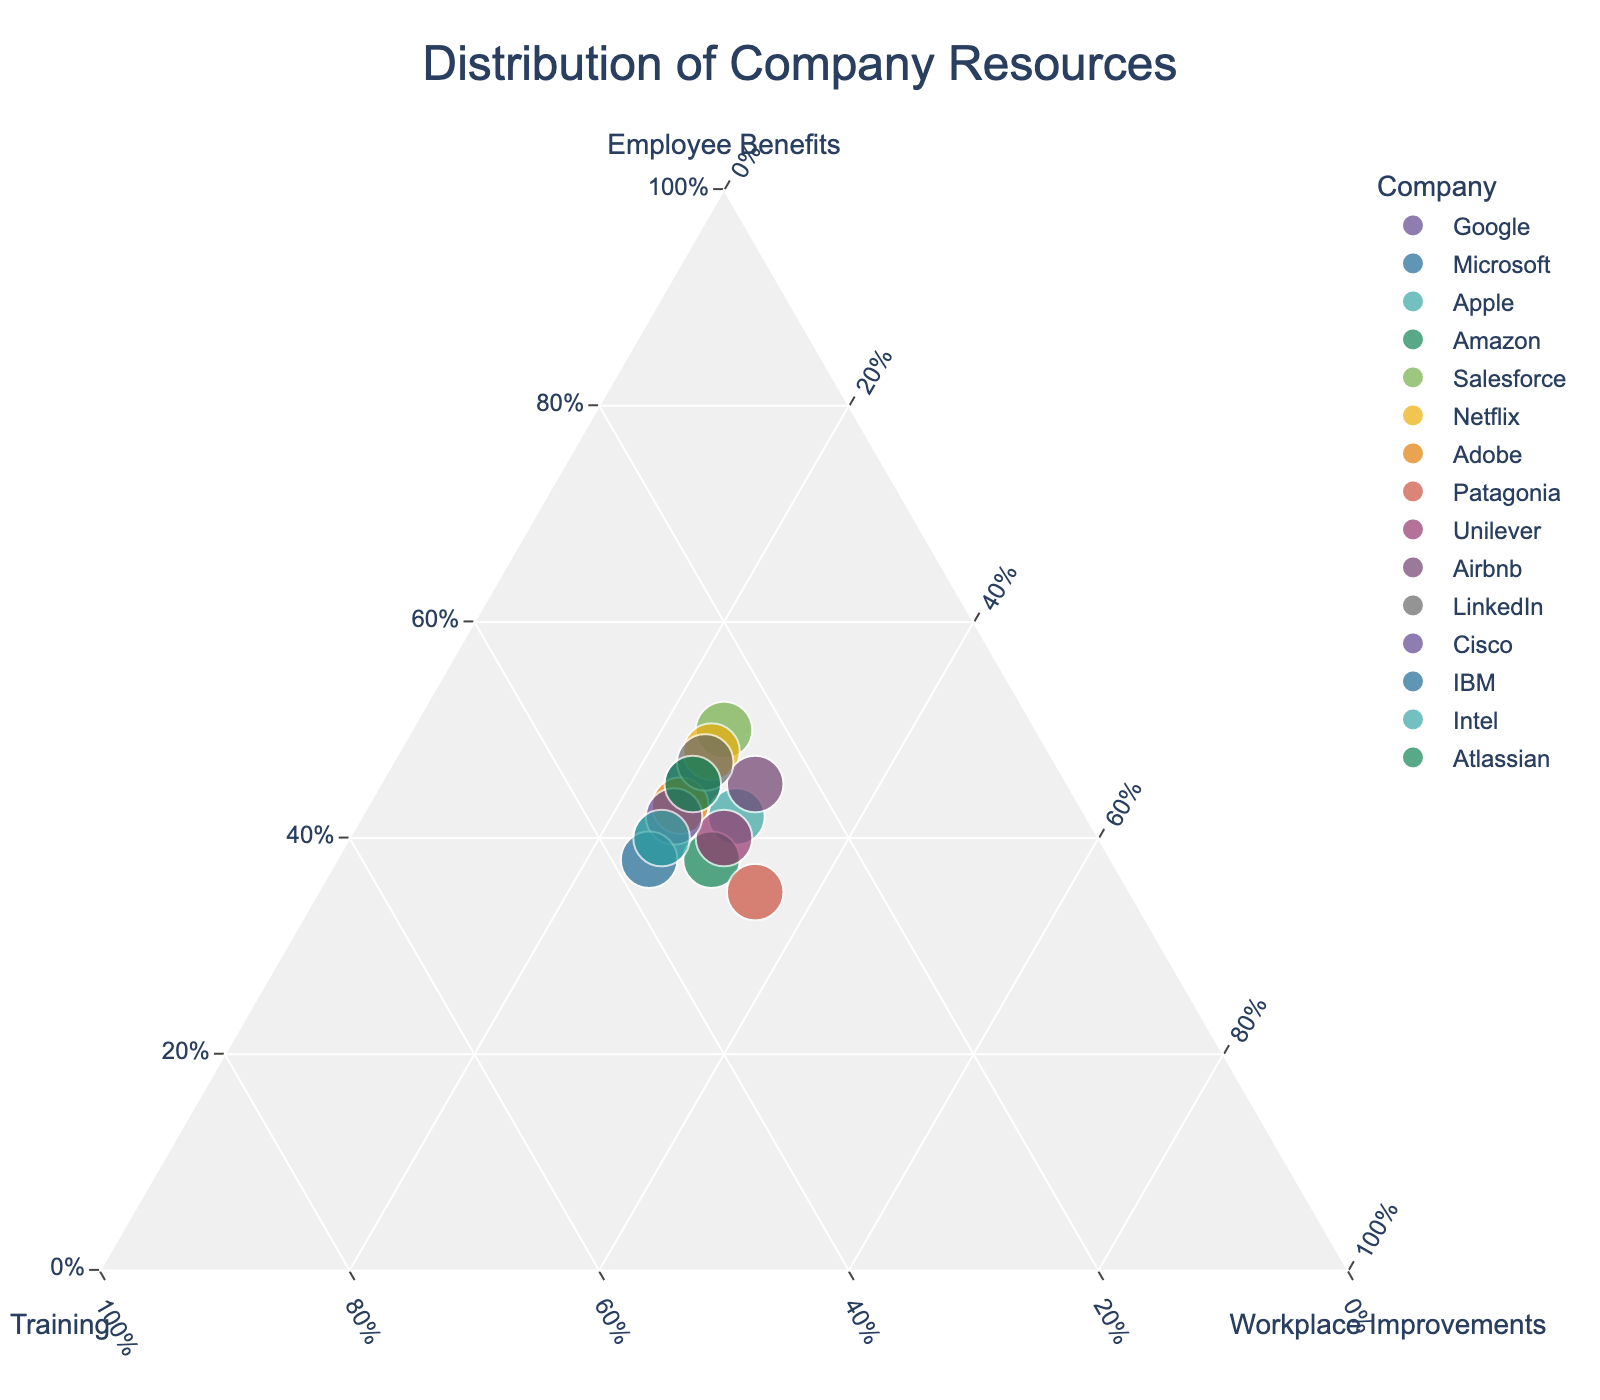What's the title of the plot? The title is typically located at the top of the plot and is displayed in larger font size for emphasis. Here, it reads "Distribution of Company Resources."
Answer: Distribution of Company Resources How many companies are represented in the plot? The number of companies can be determined by counting the distinct data points on the plot. By checking the figure, there are 15 distinct points representing different companies.
Answer: 15 Which company allocates the most significant portion of its resources to Employee Benefits? Identify the point on the ternary plot that is furthest along the axis for Employee Benefits. Salesforce allocates 50% (or 0.50 when normalized) of its resources to Employee Benefits, the highest among the companies listed.
Answer: Salesforce What is the sum of percentages allocated to Training and Workplace Improvements for Netflix? From the plot, we can see the specific allocation percentages for Netflix: 27% for Training and 25% for Workplace Improvements. Summing these percentages: 27% + 25% = 52%.
Answer: 52% How do Apple's and Amazon's distributions of resources compare in terms of Workplace Improvements? Find the points for Apple and Amazon on the plot and compare their positions relative to the Workplace Improvements axis. Both Apple and Amazon allocate 30% of their resources to Workplace Improvements.
Answer: Equal; both allocate 30% Which company has the most balanced distribution of resources among Employee Benefits, Training, and Workplace Improvements? The balanced distribution would have points closer to the center of the plot. From the data, Unilever allocates 40% to Employee Benefits, 30% to Training, and 30% to Workplace Improvements, which seems the most balanced compared to other companies.
Answer: Unilever How much more does IBM allocate to Training compared to Airbnb? IBM allocates 37% to Training, while Airbnb allocates 25%. To find the difference: 37% - 25% = 12%.
Answer: 12% Which companies dedicate exactly 25% to Workplace Improvements? By checking the points on the ternary plot, identifying those that are aligned with the 25% mark on the Workplace Improvements axis reveals that Google, Microsoft, Salesforce, Netflix, Adobe, LinkedIn, Cisco, Atlassian, and Intel all allocate exactly 25% to Workplace Improvements.
Answer: Google, Microsoft, Salesforce, Netflix, Adobe, LinkedIn, Cisco, Atlassian, Intel Is there any company that allocates more resources to Training than both Employee Benefits and Workplace Improvements? Assess each company's allocations to identify if any has a higher percentage for Training. IBM allocates 37% to Training, which is greater than its allocations to Employee Benefits (38%) and Workplace Improvements (25%). No other company follows this pattern.
Answer: IBM What are the allocations of resources for LinkedIn? For LinkedIn, find the respective percentages on the ternary plot: 47% Employee Benefits, 28% Training, and 25% Workplace Improvements. These can be read off directly from the plot.
Answer: 47% Employee Benefits, 28% Training, 25% Workplace Improvements 